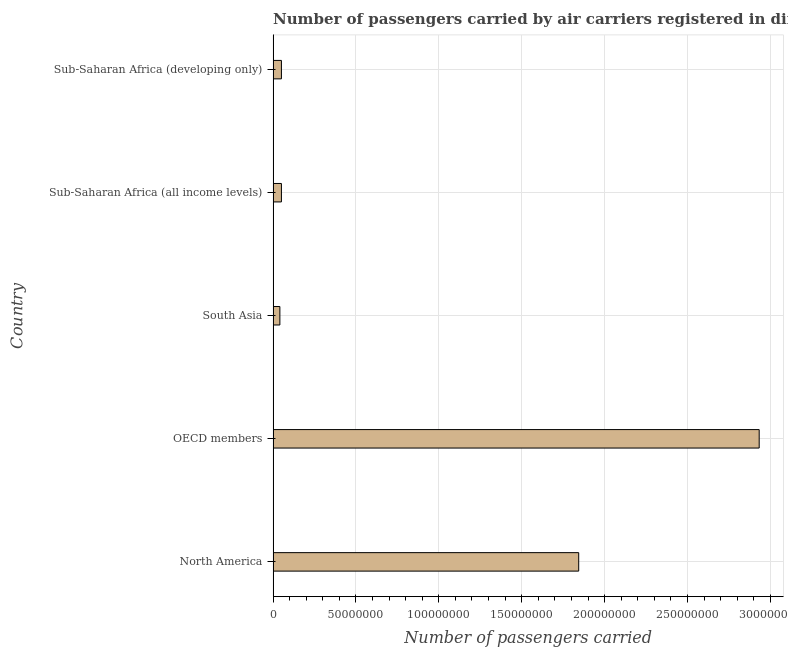Does the graph contain any zero values?
Offer a very short reply. No. Does the graph contain grids?
Offer a terse response. Yes. What is the title of the graph?
Your answer should be very brief. Number of passengers carried by air carriers registered in different countries. What is the label or title of the X-axis?
Your answer should be very brief. Number of passengers carried. What is the label or title of the Y-axis?
Offer a terse response. Country. What is the number of passengers carried in OECD members?
Make the answer very short. 2.93e+08. Across all countries, what is the maximum number of passengers carried?
Give a very brief answer. 2.93e+08. Across all countries, what is the minimum number of passengers carried?
Offer a very short reply. 4.07e+06. In which country was the number of passengers carried maximum?
Ensure brevity in your answer.  OECD members. What is the sum of the number of passengers carried?
Your response must be concise. 4.92e+08. What is the difference between the number of passengers carried in OECD members and Sub-Saharan Africa (developing only)?
Offer a very short reply. 2.88e+08. What is the average number of passengers carried per country?
Ensure brevity in your answer.  9.84e+07. What is the median number of passengers carried?
Your answer should be compact. 5.01e+06. In how many countries, is the number of passengers carried greater than 250000000 ?
Make the answer very short. 1. What is the ratio of the number of passengers carried in OECD members to that in South Asia?
Give a very brief answer. 72.05. Is the number of passengers carried in North America less than that in OECD members?
Offer a very short reply. Yes. Is the difference between the number of passengers carried in OECD members and Sub-Saharan Africa (all income levels) greater than the difference between any two countries?
Keep it short and to the point. No. What is the difference between the highest and the second highest number of passengers carried?
Your answer should be compact. 1.09e+08. Is the sum of the number of passengers carried in North America and South Asia greater than the maximum number of passengers carried across all countries?
Ensure brevity in your answer.  No. What is the difference between the highest and the lowest number of passengers carried?
Ensure brevity in your answer.  2.89e+08. In how many countries, is the number of passengers carried greater than the average number of passengers carried taken over all countries?
Offer a terse response. 2. How many bars are there?
Keep it short and to the point. 5. Are all the bars in the graph horizontal?
Your answer should be very brief. Yes. What is the difference between two consecutive major ticks on the X-axis?
Keep it short and to the point. 5.00e+07. What is the Number of passengers carried of North America?
Your answer should be very brief. 1.84e+08. What is the Number of passengers carried in OECD members?
Keep it short and to the point. 2.93e+08. What is the Number of passengers carried of South Asia?
Provide a succinct answer. 4.07e+06. What is the Number of passengers carried in Sub-Saharan Africa (all income levels)?
Your answer should be compact. 5.01e+06. What is the Number of passengers carried in Sub-Saharan Africa (developing only)?
Your answer should be compact. 5.00e+06. What is the difference between the Number of passengers carried in North America and OECD members?
Ensure brevity in your answer.  -1.09e+08. What is the difference between the Number of passengers carried in North America and South Asia?
Offer a terse response. 1.80e+08. What is the difference between the Number of passengers carried in North America and Sub-Saharan Africa (all income levels)?
Keep it short and to the point. 1.79e+08. What is the difference between the Number of passengers carried in North America and Sub-Saharan Africa (developing only)?
Your answer should be very brief. 1.79e+08. What is the difference between the Number of passengers carried in OECD members and South Asia?
Your answer should be very brief. 2.89e+08. What is the difference between the Number of passengers carried in OECD members and Sub-Saharan Africa (all income levels)?
Keep it short and to the point. 2.88e+08. What is the difference between the Number of passengers carried in OECD members and Sub-Saharan Africa (developing only)?
Your response must be concise. 2.88e+08. What is the difference between the Number of passengers carried in South Asia and Sub-Saharan Africa (all income levels)?
Your answer should be compact. -9.42e+05. What is the difference between the Number of passengers carried in South Asia and Sub-Saharan Africa (developing only)?
Offer a terse response. -9.34e+05. What is the difference between the Number of passengers carried in Sub-Saharan Africa (all income levels) and Sub-Saharan Africa (developing only)?
Give a very brief answer. 8500. What is the ratio of the Number of passengers carried in North America to that in OECD members?
Ensure brevity in your answer.  0.63. What is the ratio of the Number of passengers carried in North America to that in South Asia?
Give a very brief answer. 45.3. What is the ratio of the Number of passengers carried in North America to that in Sub-Saharan Africa (all income levels)?
Offer a terse response. 36.78. What is the ratio of the Number of passengers carried in North America to that in Sub-Saharan Africa (developing only)?
Offer a very short reply. 36.84. What is the ratio of the Number of passengers carried in OECD members to that in South Asia?
Provide a succinct answer. 72.05. What is the ratio of the Number of passengers carried in OECD members to that in Sub-Saharan Africa (all income levels)?
Make the answer very short. 58.5. What is the ratio of the Number of passengers carried in OECD members to that in Sub-Saharan Africa (developing only)?
Your answer should be compact. 58.6. What is the ratio of the Number of passengers carried in South Asia to that in Sub-Saharan Africa (all income levels)?
Your answer should be very brief. 0.81. What is the ratio of the Number of passengers carried in South Asia to that in Sub-Saharan Africa (developing only)?
Your answer should be very brief. 0.81. What is the ratio of the Number of passengers carried in Sub-Saharan Africa (all income levels) to that in Sub-Saharan Africa (developing only)?
Ensure brevity in your answer.  1. 